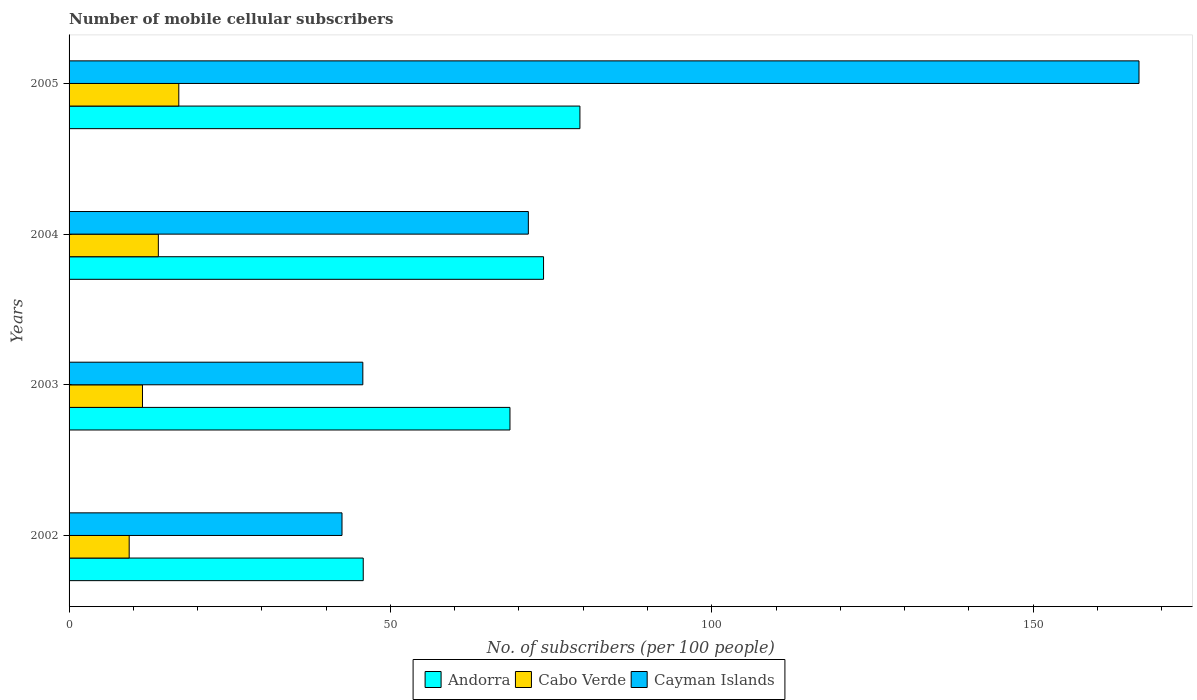How many different coloured bars are there?
Offer a very short reply. 3. How many groups of bars are there?
Your answer should be very brief. 4. How many bars are there on the 1st tick from the top?
Your response must be concise. 3. What is the label of the 1st group of bars from the top?
Provide a short and direct response. 2005. In how many cases, is the number of bars for a given year not equal to the number of legend labels?
Keep it short and to the point. 0. What is the number of mobile cellular subscribers in Andorra in 2002?
Your answer should be very brief. 45.77. Across all years, what is the maximum number of mobile cellular subscribers in Cayman Islands?
Keep it short and to the point. 166.47. Across all years, what is the minimum number of mobile cellular subscribers in Cabo Verde?
Offer a very short reply. 9.35. In which year was the number of mobile cellular subscribers in Cabo Verde maximum?
Offer a very short reply. 2005. What is the total number of mobile cellular subscribers in Cayman Islands in the graph?
Your answer should be compact. 326.11. What is the difference between the number of mobile cellular subscribers in Cayman Islands in 2004 and that in 2005?
Make the answer very short. -95.01. What is the difference between the number of mobile cellular subscribers in Cayman Islands in 2004 and the number of mobile cellular subscribers in Andorra in 2005?
Offer a terse response. -8.02. What is the average number of mobile cellular subscribers in Cabo Verde per year?
Your answer should be very brief. 12.94. In the year 2002, what is the difference between the number of mobile cellular subscribers in Andorra and number of mobile cellular subscribers in Cabo Verde?
Your response must be concise. 36.42. What is the ratio of the number of mobile cellular subscribers in Andorra in 2002 to that in 2003?
Provide a short and direct response. 0.67. Is the number of mobile cellular subscribers in Cayman Islands in 2004 less than that in 2005?
Provide a short and direct response. Yes. What is the difference between the highest and the second highest number of mobile cellular subscribers in Andorra?
Your response must be concise. 5.66. What is the difference between the highest and the lowest number of mobile cellular subscribers in Cayman Islands?
Provide a succinct answer. 124.01. In how many years, is the number of mobile cellular subscribers in Cayman Islands greater than the average number of mobile cellular subscribers in Cayman Islands taken over all years?
Provide a succinct answer. 1. What does the 3rd bar from the top in 2003 represents?
Offer a very short reply. Andorra. What does the 2nd bar from the bottom in 2004 represents?
Your answer should be very brief. Cabo Verde. Is it the case that in every year, the sum of the number of mobile cellular subscribers in Cabo Verde and number of mobile cellular subscribers in Cayman Islands is greater than the number of mobile cellular subscribers in Andorra?
Give a very brief answer. No. How many bars are there?
Provide a short and direct response. 12. How many years are there in the graph?
Provide a succinct answer. 4. Does the graph contain any zero values?
Provide a short and direct response. No. Does the graph contain grids?
Your answer should be very brief. No. How many legend labels are there?
Provide a succinct answer. 3. How are the legend labels stacked?
Ensure brevity in your answer.  Horizontal. What is the title of the graph?
Offer a terse response. Number of mobile cellular subscribers. Does "Bosnia and Herzegovina" appear as one of the legend labels in the graph?
Keep it short and to the point. No. What is the label or title of the X-axis?
Ensure brevity in your answer.  No. of subscribers (per 100 people). What is the label or title of the Y-axis?
Provide a short and direct response. Years. What is the No. of subscribers (per 100 people) in Andorra in 2002?
Your answer should be compact. 45.77. What is the No. of subscribers (per 100 people) in Cabo Verde in 2002?
Keep it short and to the point. 9.35. What is the No. of subscribers (per 100 people) of Cayman Islands in 2002?
Your answer should be very brief. 42.47. What is the No. of subscribers (per 100 people) in Andorra in 2003?
Give a very brief answer. 68.6. What is the No. of subscribers (per 100 people) in Cabo Verde in 2003?
Your answer should be compact. 11.42. What is the No. of subscribers (per 100 people) of Cayman Islands in 2003?
Keep it short and to the point. 45.71. What is the No. of subscribers (per 100 people) in Andorra in 2004?
Offer a terse response. 73.82. What is the No. of subscribers (per 100 people) in Cabo Verde in 2004?
Keep it short and to the point. 13.89. What is the No. of subscribers (per 100 people) of Cayman Islands in 2004?
Your answer should be very brief. 71.46. What is the No. of subscribers (per 100 people) of Andorra in 2005?
Ensure brevity in your answer.  79.48. What is the No. of subscribers (per 100 people) in Cabo Verde in 2005?
Ensure brevity in your answer.  17.07. What is the No. of subscribers (per 100 people) in Cayman Islands in 2005?
Give a very brief answer. 166.47. Across all years, what is the maximum No. of subscribers (per 100 people) of Andorra?
Offer a very short reply. 79.48. Across all years, what is the maximum No. of subscribers (per 100 people) in Cabo Verde?
Offer a terse response. 17.07. Across all years, what is the maximum No. of subscribers (per 100 people) of Cayman Islands?
Offer a very short reply. 166.47. Across all years, what is the minimum No. of subscribers (per 100 people) in Andorra?
Keep it short and to the point. 45.77. Across all years, what is the minimum No. of subscribers (per 100 people) in Cabo Verde?
Offer a terse response. 9.35. Across all years, what is the minimum No. of subscribers (per 100 people) in Cayman Islands?
Offer a very short reply. 42.47. What is the total No. of subscribers (per 100 people) in Andorra in the graph?
Provide a short and direct response. 267.68. What is the total No. of subscribers (per 100 people) in Cabo Verde in the graph?
Your response must be concise. 51.74. What is the total No. of subscribers (per 100 people) of Cayman Islands in the graph?
Give a very brief answer. 326.11. What is the difference between the No. of subscribers (per 100 people) in Andorra in 2002 and that in 2003?
Provide a succinct answer. -22.83. What is the difference between the No. of subscribers (per 100 people) in Cabo Verde in 2002 and that in 2003?
Offer a very short reply. -2.07. What is the difference between the No. of subscribers (per 100 people) of Cayman Islands in 2002 and that in 2003?
Offer a terse response. -3.24. What is the difference between the No. of subscribers (per 100 people) in Andorra in 2002 and that in 2004?
Give a very brief answer. -28.05. What is the difference between the No. of subscribers (per 100 people) of Cabo Verde in 2002 and that in 2004?
Ensure brevity in your answer.  -4.54. What is the difference between the No. of subscribers (per 100 people) of Cayman Islands in 2002 and that in 2004?
Offer a terse response. -28.99. What is the difference between the No. of subscribers (per 100 people) in Andorra in 2002 and that in 2005?
Keep it short and to the point. -33.71. What is the difference between the No. of subscribers (per 100 people) of Cabo Verde in 2002 and that in 2005?
Offer a very short reply. -7.72. What is the difference between the No. of subscribers (per 100 people) of Cayman Islands in 2002 and that in 2005?
Your answer should be very brief. -124.01. What is the difference between the No. of subscribers (per 100 people) in Andorra in 2003 and that in 2004?
Offer a very short reply. -5.22. What is the difference between the No. of subscribers (per 100 people) in Cabo Verde in 2003 and that in 2004?
Provide a succinct answer. -2.47. What is the difference between the No. of subscribers (per 100 people) of Cayman Islands in 2003 and that in 2004?
Keep it short and to the point. -25.75. What is the difference between the No. of subscribers (per 100 people) in Andorra in 2003 and that in 2005?
Ensure brevity in your answer.  -10.88. What is the difference between the No. of subscribers (per 100 people) of Cabo Verde in 2003 and that in 2005?
Your answer should be very brief. -5.65. What is the difference between the No. of subscribers (per 100 people) of Cayman Islands in 2003 and that in 2005?
Your answer should be very brief. -120.77. What is the difference between the No. of subscribers (per 100 people) in Andorra in 2004 and that in 2005?
Provide a short and direct response. -5.66. What is the difference between the No. of subscribers (per 100 people) in Cabo Verde in 2004 and that in 2005?
Provide a succinct answer. -3.18. What is the difference between the No. of subscribers (per 100 people) in Cayman Islands in 2004 and that in 2005?
Your answer should be compact. -95.01. What is the difference between the No. of subscribers (per 100 people) of Andorra in 2002 and the No. of subscribers (per 100 people) of Cabo Verde in 2003?
Offer a terse response. 34.35. What is the difference between the No. of subscribers (per 100 people) in Andorra in 2002 and the No. of subscribers (per 100 people) in Cayman Islands in 2003?
Offer a very short reply. 0.06. What is the difference between the No. of subscribers (per 100 people) in Cabo Verde in 2002 and the No. of subscribers (per 100 people) in Cayman Islands in 2003?
Your response must be concise. -36.35. What is the difference between the No. of subscribers (per 100 people) in Andorra in 2002 and the No. of subscribers (per 100 people) in Cabo Verde in 2004?
Keep it short and to the point. 31.88. What is the difference between the No. of subscribers (per 100 people) of Andorra in 2002 and the No. of subscribers (per 100 people) of Cayman Islands in 2004?
Your response must be concise. -25.69. What is the difference between the No. of subscribers (per 100 people) in Cabo Verde in 2002 and the No. of subscribers (per 100 people) in Cayman Islands in 2004?
Give a very brief answer. -62.11. What is the difference between the No. of subscribers (per 100 people) of Andorra in 2002 and the No. of subscribers (per 100 people) of Cabo Verde in 2005?
Provide a succinct answer. 28.7. What is the difference between the No. of subscribers (per 100 people) of Andorra in 2002 and the No. of subscribers (per 100 people) of Cayman Islands in 2005?
Your answer should be compact. -120.7. What is the difference between the No. of subscribers (per 100 people) in Cabo Verde in 2002 and the No. of subscribers (per 100 people) in Cayman Islands in 2005?
Offer a very short reply. -157.12. What is the difference between the No. of subscribers (per 100 people) of Andorra in 2003 and the No. of subscribers (per 100 people) of Cabo Verde in 2004?
Your answer should be very brief. 54.71. What is the difference between the No. of subscribers (per 100 people) of Andorra in 2003 and the No. of subscribers (per 100 people) of Cayman Islands in 2004?
Your response must be concise. -2.86. What is the difference between the No. of subscribers (per 100 people) in Cabo Verde in 2003 and the No. of subscribers (per 100 people) in Cayman Islands in 2004?
Provide a short and direct response. -60.04. What is the difference between the No. of subscribers (per 100 people) of Andorra in 2003 and the No. of subscribers (per 100 people) of Cabo Verde in 2005?
Offer a very short reply. 51.53. What is the difference between the No. of subscribers (per 100 people) in Andorra in 2003 and the No. of subscribers (per 100 people) in Cayman Islands in 2005?
Your answer should be very brief. -97.87. What is the difference between the No. of subscribers (per 100 people) in Cabo Verde in 2003 and the No. of subscribers (per 100 people) in Cayman Islands in 2005?
Give a very brief answer. -155.05. What is the difference between the No. of subscribers (per 100 people) of Andorra in 2004 and the No. of subscribers (per 100 people) of Cabo Verde in 2005?
Your answer should be very brief. 56.75. What is the difference between the No. of subscribers (per 100 people) of Andorra in 2004 and the No. of subscribers (per 100 people) of Cayman Islands in 2005?
Keep it short and to the point. -92.65. What is the difference between the No. of subscribers (per 100 people) in Cabo Verde in 2004 and the No. of subscribers (per 100 people) in Cayman Islands in 2005?
Offer a terse response. -152.58. What is the average No. of subscribers (per 100 people) of Andorra per year?
Your answer should be very brief. 66.92. What is the average No. of subscribers (per 100 people) of Cabo Verde per year?
Your answer should be compact. 12.94. What is the average No. of subscribers (per 100 people) in Cayman Islands per year?
Offer a very short reply. 81.53. In the year 2002, what is the difference between the No. of subscribers (per 100 people) of Andorra and No. of subscribers (per 100 people) of Cabo Verde?
Keep it short and to the point. 36.42. In the year 2002, what is the difference between the No. of subscribers (per 100 people) in Andorra and No. of subscribers (per 100 people) in Cayman Islands?
Your response must be concise. 3.31. In the year 2002, what is the difference between the No. of subscribers (per 100 people) of Cabo Verde and No. of subscribers (per 100 people) of Cayman Islands?
Offer a very short reply. -33.11. In the year 2003, what is the difference between the No. of subscribers (per 100 people) in Andorra and No. of subscribers (per 100 people) in Cabo Verde?
Your answer should be compact. 57.18. In the year 2003, what is the difference between the No. of subscribers (per 100 people) in Andorra and No. of subscribers (per 100 people) in Cayman Islands?
Ensure brevity in your answer.  22.9. In the year 2003, what is the difference between the No. of subscribers (per 100 people) in Cabo Verde and No. of subscribers (per 100 people) in Cayman Islands?
Ensure brevity in your answer.  -34.28. In the year 2004, what is the difference between the No. of subscribers (per 100 people) in Andorra and No. of subscribers (per 100 people) in Cabo Verde?
Your answer should be compact. 59.93. In the year 2004, what is the difference between the No. of subscribers (per 100 people) in Andorra and No. of subscribers (per 100 people) in Cayman Islands?
Offer a very short reply. 2.36. In the year 2004, what is the difference between the No. of subscribers (per 100 people) in Cabo Verde and No. of subscribers (per 100 people) in Cayman Islands?
Ensure brevity in your answer.  -57.57. In the year 2005, what is the difference between the No. of subscribers (per 100 people) in Andorra and No. of subscribers (per 100 people) in Cabo Verde?
Give a very brief answer. 62.41. In the year 2005, what is the difference between the No. of subscribers (per 100 people) of Andorra and No. of subscribers (per 100 people) of Cayman Islands?
Provide a succinct answer. -86.99. In the year 2005, what is the difference between the No. of subscribers (per 100 people) in Cabo Verde and No. of subscribers (per 100 people) in Cayman Islands?
Make the answer very short. -149.4. What is the ratio of the No. of subscribers (per 100 people) of Andorra in 2002 to that in 2003?
Provide a succinct answer. 0.67. What is the ratio of the No. of subscribers (per 100 people) in Cabo Verde in 2002 to that in 2003?
Offer a very short reply. 0.82. What is the ratio of the No. of subscribers (per 100 people) in Cayman Islands in 2002 to that in 2003?
Provide a short and direct response. 0.93. What is the ratio of the No. of subscribers (per 100 people) in Andorra in 2002 to that in 2004?
Make the answer very short. 0.62. What is the ratio of the No. of subscribers (per 100 people) of Cabo Verde in 2002 to that in 2004?
Make the answer very short. 0.67. What is the ratio of the No. of subscribers (per 100 people) of Cayman Islands in 2002 to that in 2004?
Keep it short and to the point. 0.59. What is the ratio of the No. of subscribers (per 100 people) in Andorra in 2002 to that in 2005?
Your answer should be very brief. 0.58. What is the ratio of the No. of subscribers (per 100 people) in Cabo Verde in 2002 to that in 2005?
Ensure brevity in your answer.  0.55. What is the ratio of the No. of subscribers (per 100 people) in Cayman Islands in 2002 to that in 2005?
Your response must be concise. 0.26. What is the ratio of the No. of subscribers (per 100 people) in Andorra in 2003 to that in 2004?
Give a very brief answer. 0.93. What is the ratio of the No. of subscribers (per 100 people) in Cabo Verde in 2003 to that in 2004?
Your response must be concise. 0.82. What is the ratio of the No. of subscribers (per 100 people) in Cayman Islands in 2003 to that in 2004?
Your answer should be very brief. 0.64. What is the ratio of the No. of subscribers (per 100 people) in Andorra in 2003 to that in 2005?
Your answer should be compact. 0.86. What is the ratio of the No. of subscribers (per 100 people) in Cabo Verde in 2003 to that in 2005?
Ensure brevity in your answer.  0.67. What is the ratio of the No. of subscribers (per 100 people) in Cayman Islands in 2003 to that in 2005?
Keep it short and to the point. 0.27. What is the ratio of the No. of subscribers (per 100 people) in Andorra in 2004 to that in 2005?
Offer a terse response. 0.93. What is the ratio of the No. of subscribers (per 100 people) of Cabo Verde in 2004 to that in 2005?
Make the answer very short. 0.81. What is the ratio of the No. of subscribers (per 100 people) of Cayman Islands in 2004 to that in 2005?
Make the answer very short. 0.43. What is the difference between the highest and the second highest No. of subscribers (per 100 people) of Andorra?
Your answer should be compact. 5.66. What is the difference between the highest and the second highest No. of subscribers (per 100 people) of Cabo Verde?
Your response must be concise. 3.18. What is the difference between the highest and the second highest No. of subscribers (per 100 people) in Cayman Islands?
Keep it short and to the point. 95.01. What is the difference between the highest and the lowest No. of subscribers (per 100 people) of Andorra?
Give a very brief answer. 33.71. What is the difference between the highest and the lowest No. of subscribers (per 100 people) in Cabo Verde?
Your answer should be very brief. 7.72. What is the difference between the highest and the lowest No. of subscribers (per 100 people) in Cayman Islands?
Offer a terse response. 124.01. 